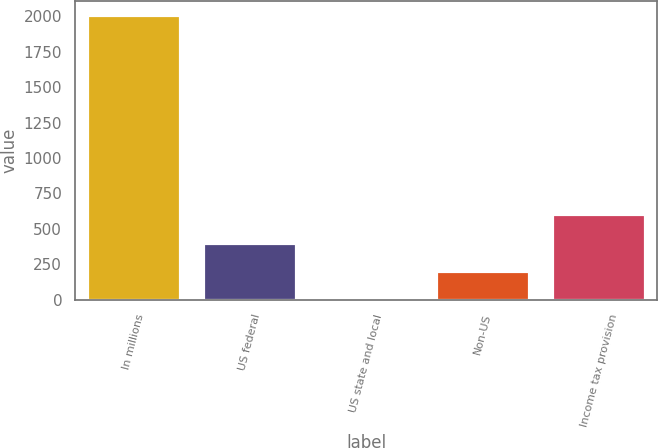Convert chart to OTSL. <chart><loc_0><loc_0><loc_500><loc_500><bar_chart><fcel>In millions<fcel>US federal<fcel>US state and local<fcel>Non-US<fcel>Income tax provision<nl><fcel>2008<fcel>403.2<fcel>2<fcel>202.6<fcel>603.8<nl></chart> 